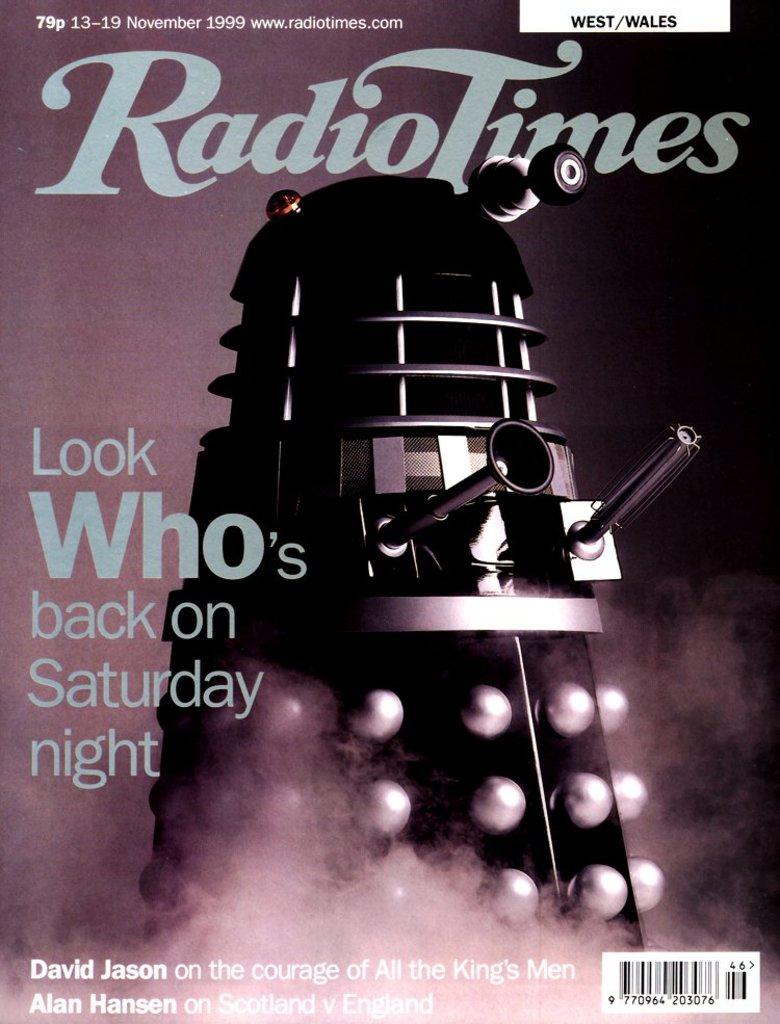Where will this be happening?
Provide a short and direct response. Saturday night. What year was this published?
Offer a very short reply. 1999. 